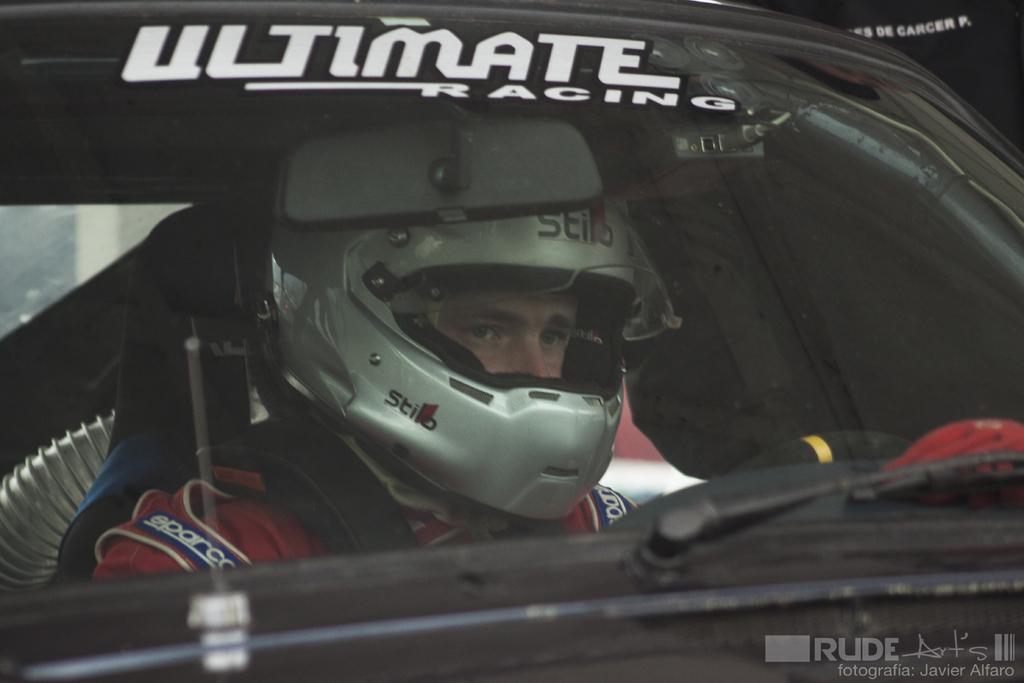How would you summarize this image in a sentence or two? In this picture there is a man who is wearing helmet and jacket. He is sitting inside the car. On the bottom right corner there is a watermark. On the left we can see a wall. 